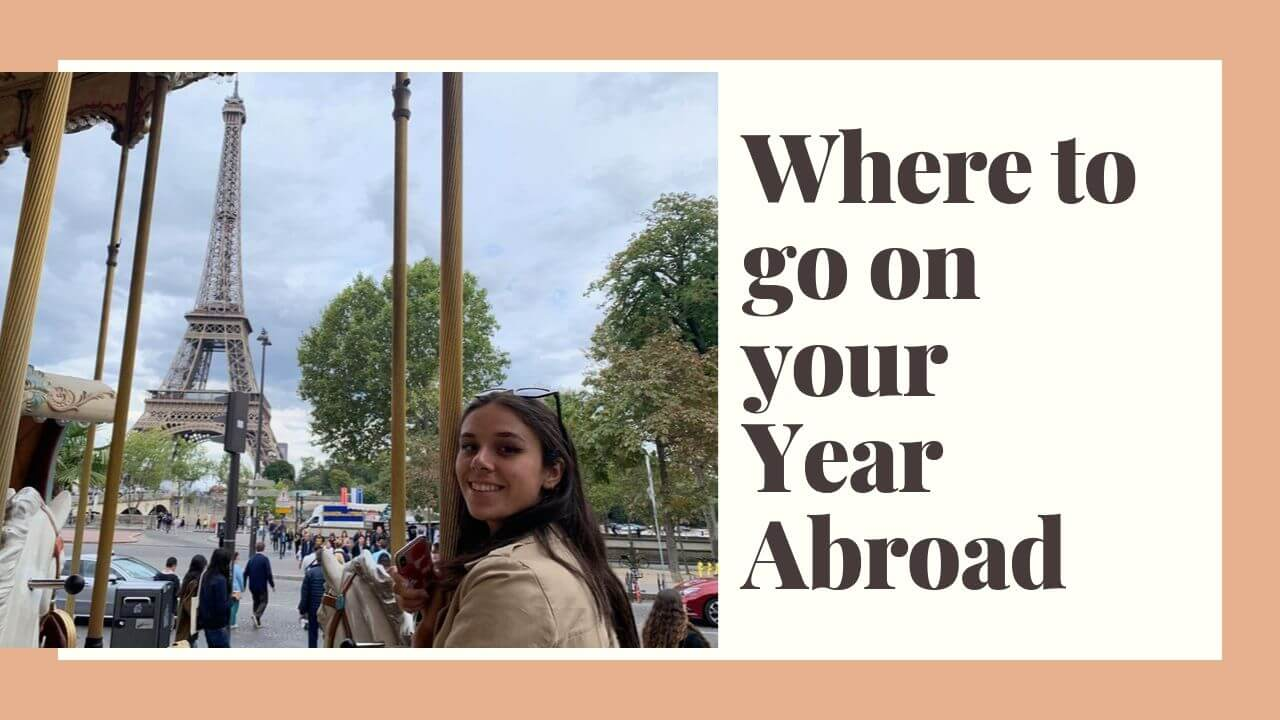What practical advice could the graphic be giving to its target audience about preparing for a year abroad? The graphic might be advising its target audience to embrace the spirit of adventure and cultural immersion when preparing for a year abroad. Practical tips could include learning some basic phrases in the local language, packing versatile and comfortable clothing, researching cultural norms and local laws, and staying open to new experiences. Additionally, it might suggest planning visits to iconic landmarks and off-the-beaten-path locations to create a well-rounded and memorable experience. 